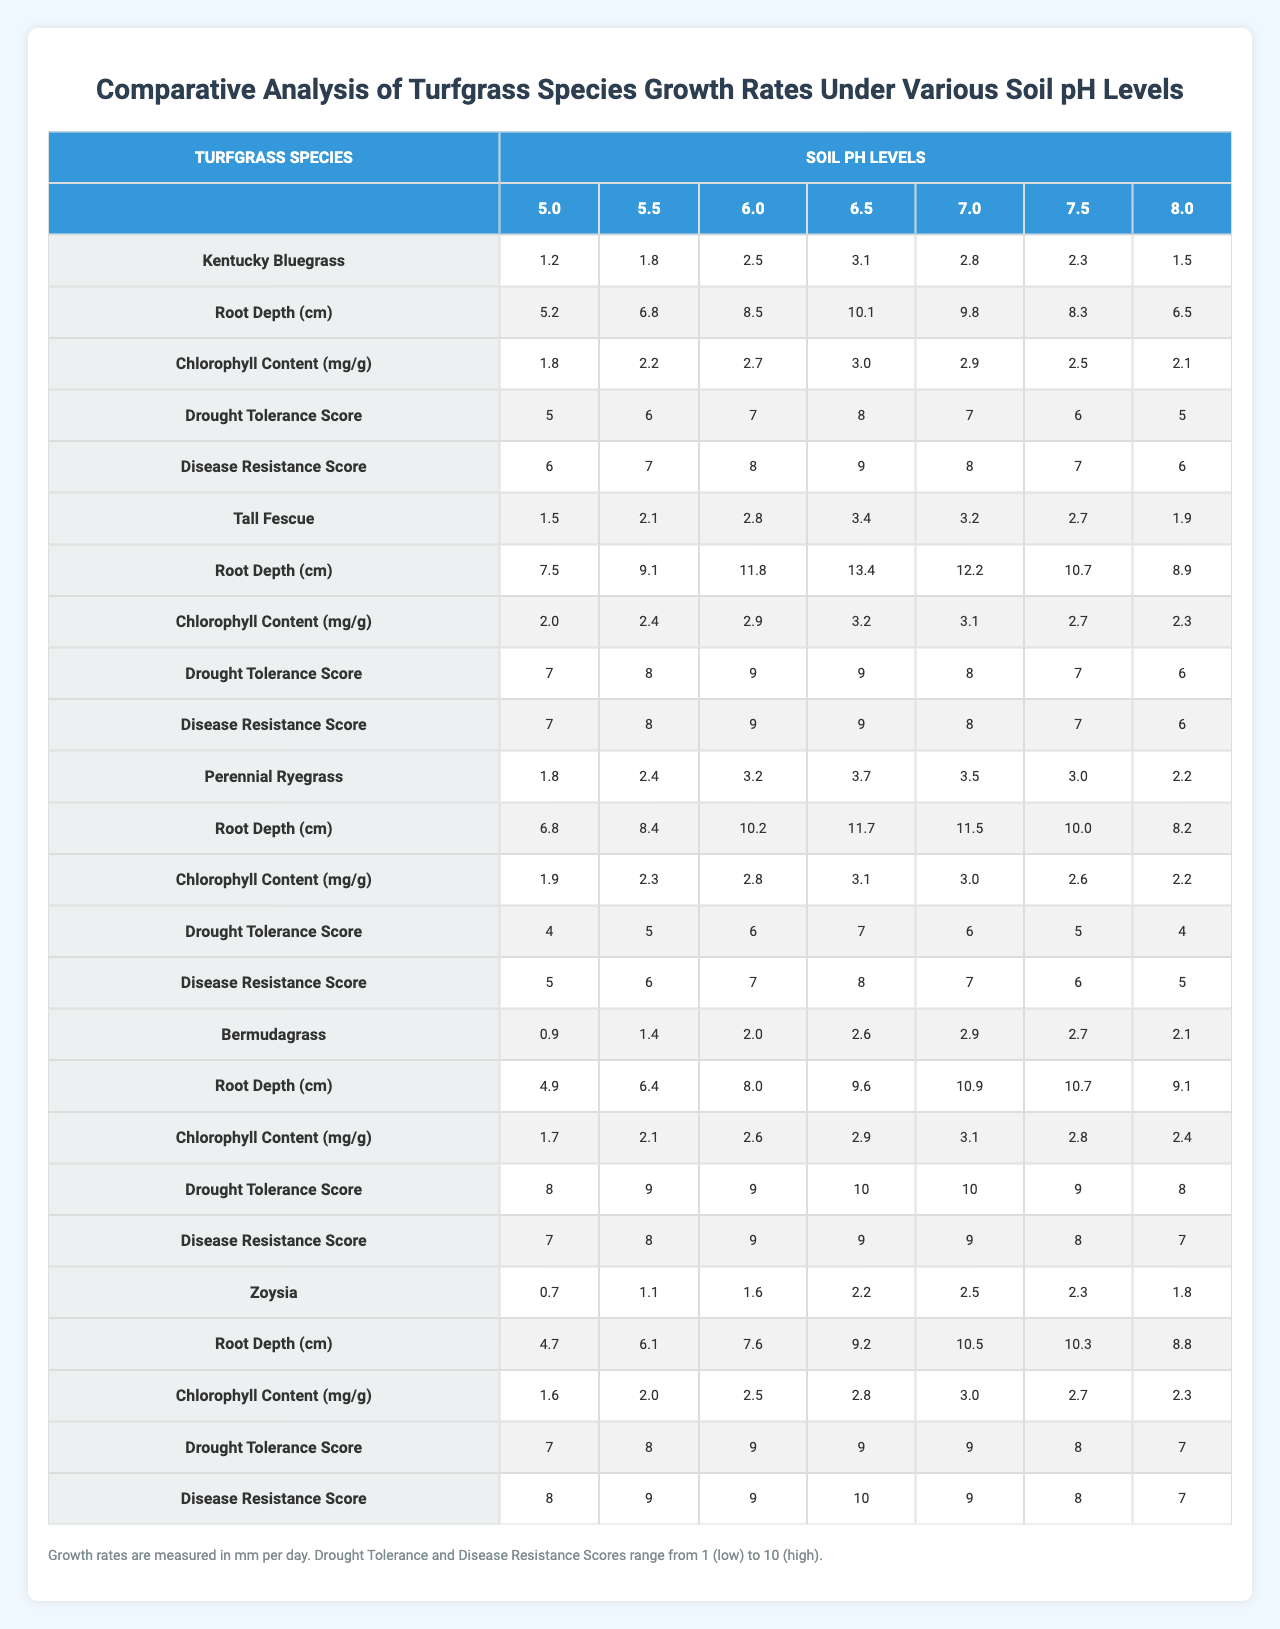What is the growth rate of Kentucky Bluegrass at a soil pH of 6.0? The table shows the growth rates for Kentucky Bluegrass under various soil pH levels, and for a pH of 6.0, the growth rate is 2.5 mm per day.
Answer: 2.5 mm per day What is the root depth of Tall Fescue at a soil pH of 7.5? The table indicates that for Tall Fescue, the root depth at a soil pH of 7.5 is 10.7 cm.
Answer: 10.7 cm Does Bermudagrass have a higher growth rate at pH 6.5 than Zoysia at pH 6.5? Comparing the growth rates at pH 6.5, Bermudagrass has a rate of 2.6 mm per day while Zoysia has a rate of 2.2 mm per day, which shows that Bermudagrass does have a higher growth rate.
Answer: Yes Which turfgrass species has the highest drought tolerance score at pH 6.0? Assessing the drought tolerance scores at pH 6.0, Kentucky Bluegrass has a score of 7, Tall Fescue has a score of 9, Perennial Ryegrass has a score of 6, Bermudagrass has a score of 9, and Zoysia has a score of 9. The highest score is 9, shared by Tall Fescue, Bermudagrass, and Zoysia.
Answer: Tall Fescue, Bermudagrass, Zoysia What is the average chlorophyll content of Perennial Ryegrass across all soil pH levels? The chlorophyll content for Perennial Ryegrass across the listed soil pH levels is [1.9, 2.3, 2.8, 3.1, 3.0, 2.6, 2.2]. To find the average: (1.9 + 2.3 + 2.8 + 3.1 + 3.0 + 2.6 + 2.2) / 7 = 2.5 mg/g.
Answer: 2.5 mg/g Which turfgrass species has the lowest disease resistance score at pH 5.0? Looking at the disease resistance scores at pH 5.0: Kentucky Bluegrass is 6, Tall Fescue is 7, Perennial Ryegrass is 5, Bermudagrass is 7, and Zoysia is 8. Perennial Ryegrass has the lowest score of 5.
Answer: Perennial Ryegrass What is the difference between the maximum and minimum growth rates of Zoysia across all pH levels? The growth rates of Zoysia at different pH levels are [0.7, 1.1, 1.6, 2.2, 2.5, 2.3, 1.8]. The maximum growth rate is 2.5 mm per day, and the minimum is 0.7 mm per day. The difference is 2.5 - 0.7 = 1.8 mm per day.
Answer: 1.8 mm per day How does the average root depth of Kentucky Bluegrass compare to that of Bermudagrass? The average root depth for Kentucky Bluegrass is calculated as (5.2 + 6.8 + 8.5 + 10.1 + 9.8 + 8.3 + 6.5) / 7 = 7.4 cm. Bermudagrass has an average root depth of (4.9 + 6.4 + 8.0 + 9.6 + 10.9 + 10.7 + 9.1) / 7 = 8.3 cm. Therefore, Kentucky Bluegrass has a lower average root depth than Bermudagrass.
Answer: Kentucky Bluegrass has a lower average root depth What is the growth rate trend for Tall Fescue as soil pH levels increase? Observing Tall Fescue's growth rates across the pH levels [1.5, 2.1, 2.8, 3.4, 3.2, 2.7, 1.9], we see a general increasing trend from pH 5.0 to 6.5, but a decline when moving from pH 6.5 to 7.0 and another drop at 7.5 and 8.0. This indicates an initial increase followed by a decline at higher pH levels.
Answer: Increases to pH 6.5 then declines Which species shows the highest growth rate at soil pH 7.0? At a pH of 7.0, the growth rates are as follows: Kentucky Bluegrass = 2.8 mm/day, Tall Fescue = 3.2 mm/day, Perennial Ryegrass = 3.5 mm/day, Bermudagrass = 2.9 mm/day, Zoysia = 2.5 mm/day. Therefore, Perennial Ryegrass has the highest growth rate at this pH level.
Answer: Perennial Ryegrass 